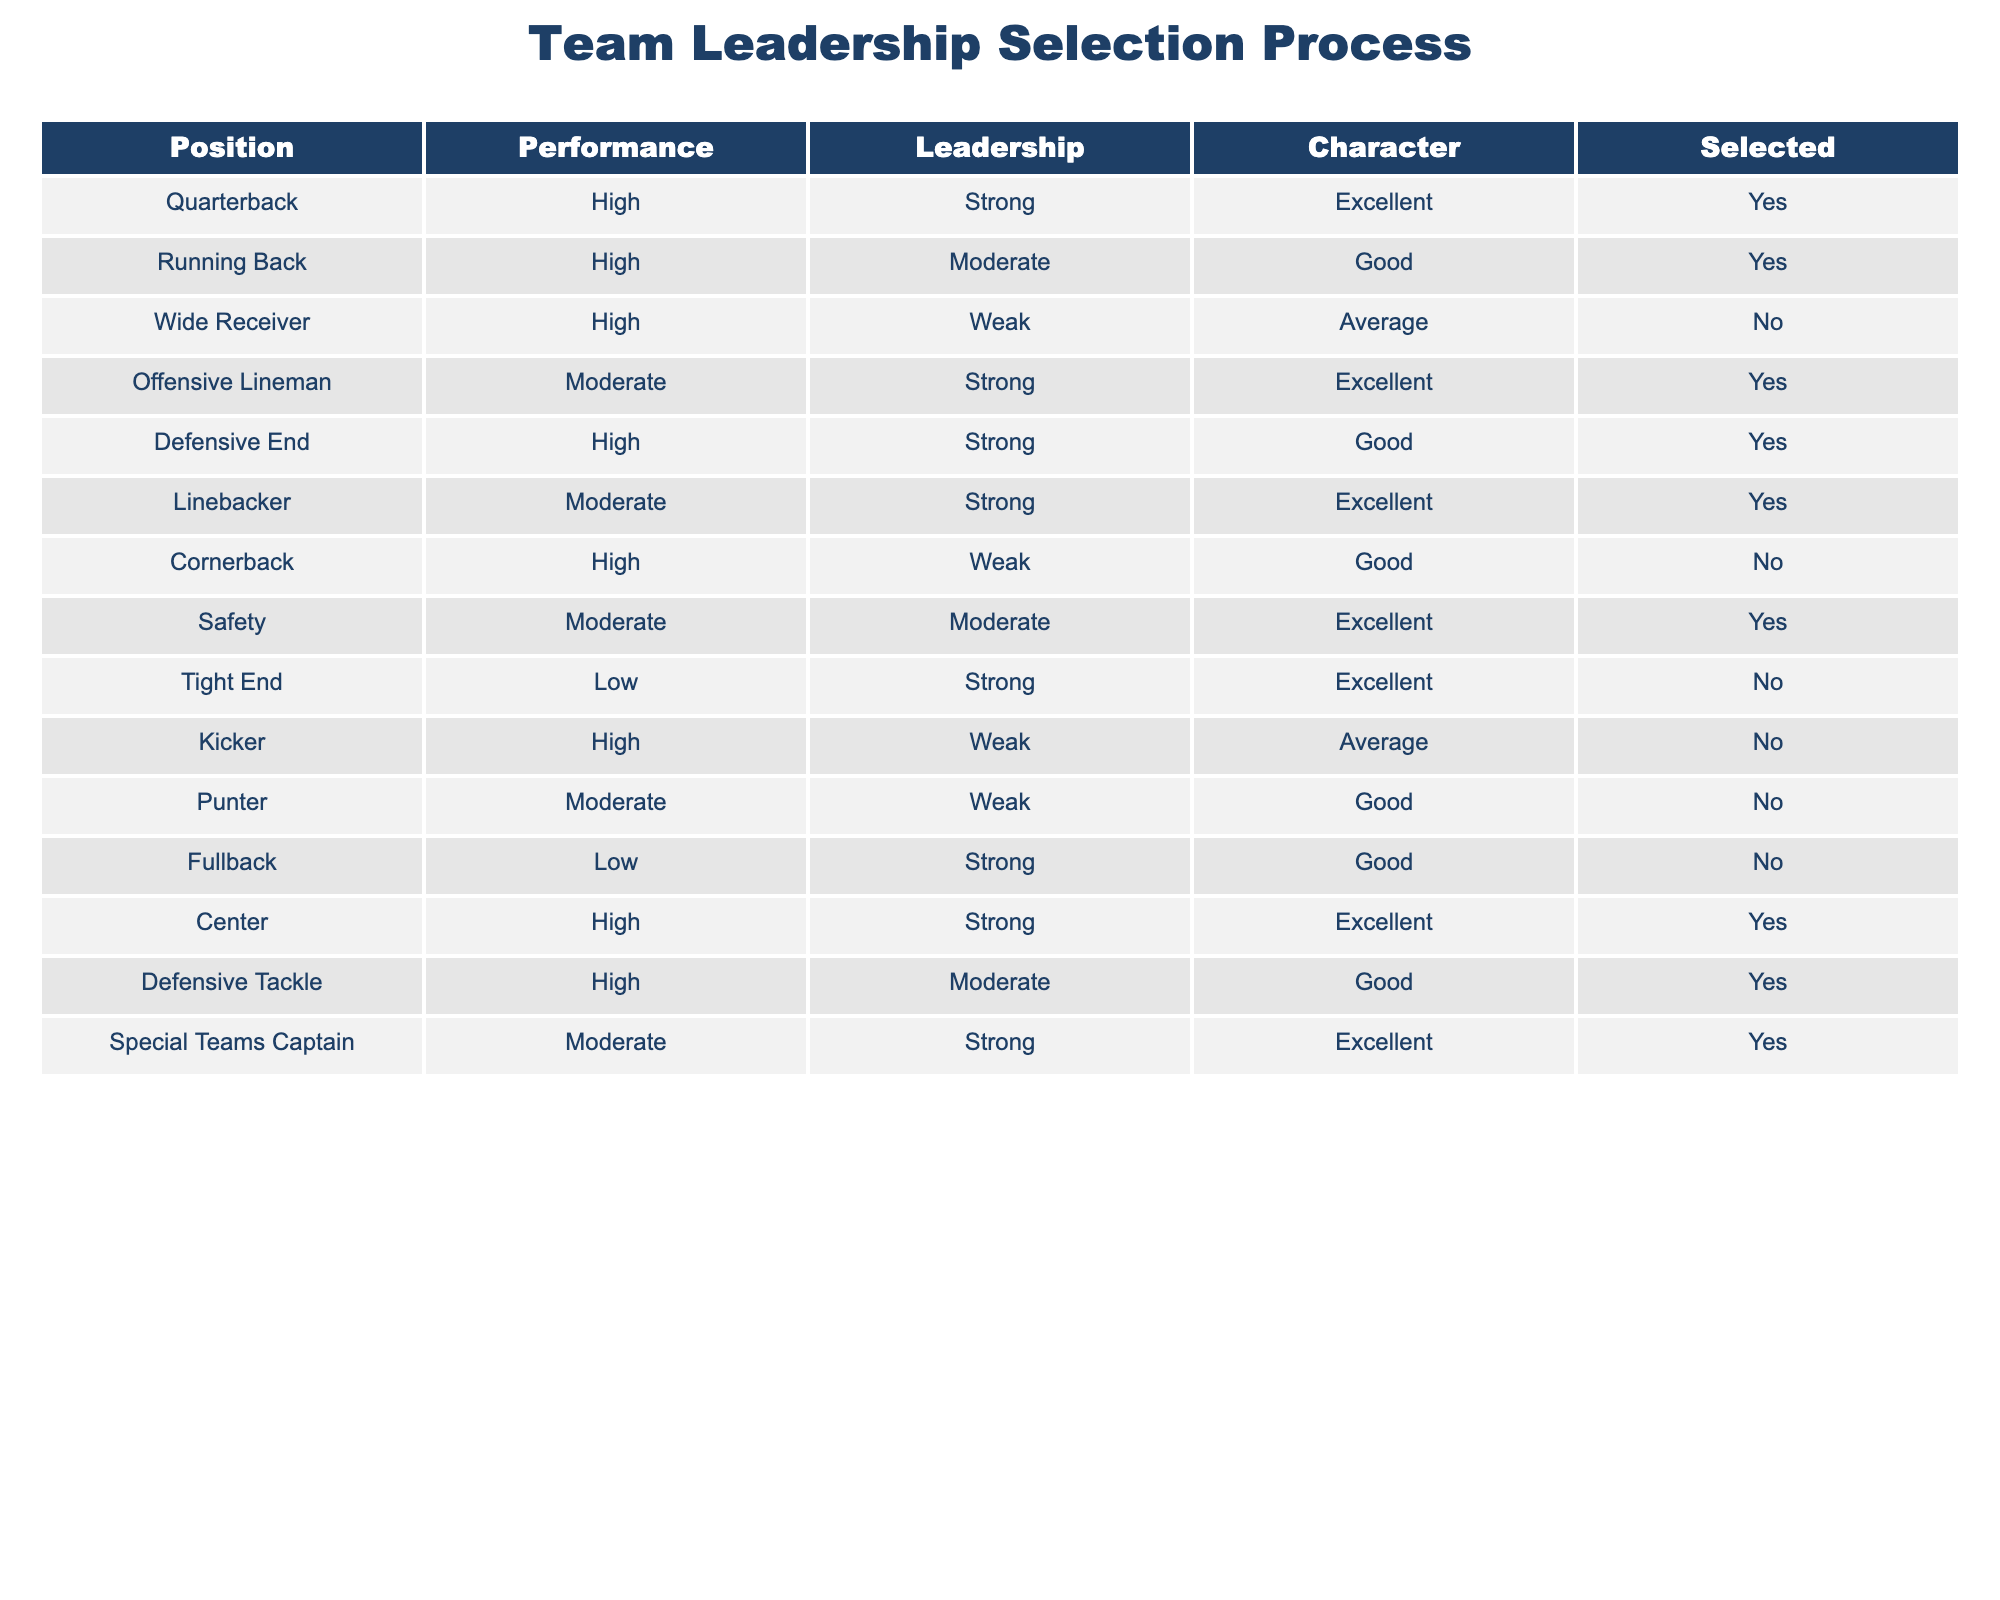What positions were selected based on strong leadership? The selected positions with strong leadership are Quarterback, Offensive Lineman, Defensive End, Linebacker, Center, and Special Teams Captain. By filtering the table for rows where the Leadership column is "Strong" and the Selected column is "Yes," we can identify these specific roles.
Answer: Quarterback, Offensive Lineman, Defensive End, Linebacker, Center, Special Teams Captain How many players with high performance were not selected? The players with high performance who were not selected are Wide Receiver and Cornerback. We count the occurrences of "High" in the Performance column and "No" in the Selected column for those two positions.
Answer: 2 Is it true that all players with excellent character traits were selected? This statement is false. While many players with excellent character traits were selected, the Tight End was not selected despite having excellent character traits. By checking the Character column for "Excellent" and the Selected column for "No," we find this discrepancy.
Answer: No What is the average performance level of selected players? The selected players show a mix of performance levels: Quarterback (High), Running Back (High), Offensive Lineman (Moderate), Defensive End (High), Linebacker (Moderate), Safety (Moderate), Center (High), Defensive Tackle (High), and Special Teams Captain (Moderate). Converting High, Moderate, and Low into numerical values (High=3, Moderate=2, Low=1), we sum them up: 3 + 3 + 2 + 3 + 2 + 2 + 3 + 3 + 2 = 21. There are 9 selected players, so the average performance level is 21/9 = 2.33.
Answer: 2.33 Which positions have moderate leadership but were not selected? The positions with moderate leadership that were not selected include Safety and Punter. We check the Leadership column for "Moderate" and the Selected column for "No," resulting in these two positions.
Answer: Safety, Punter 